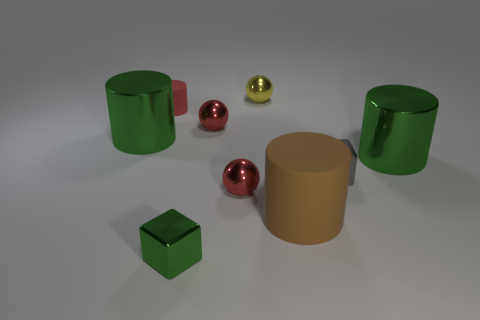Add 1 cylinders. How many objects exist? 10 Subtract all cylinders. How many objects are left? 5 Subtract 0 gray spheres. How many objects are left? 9 Subtract all yellow metal balls. Subtract all large green metal cylinders. How many objects are left? 6 Add 4 tiny spheres. How many tiny spheres are left? 7 Add 3 big matte things. How many big matte things exist? 4 